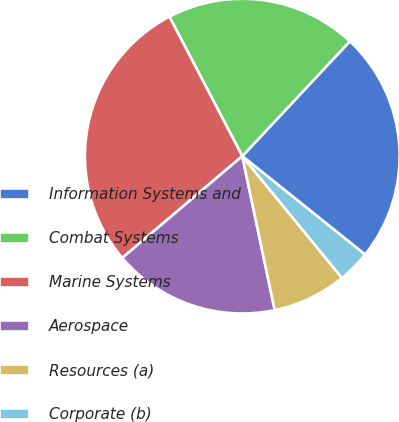Convert chart. <chart><loc_0><loc_0><loc_500><loc_500><pie_chart><fcel>Information Systems and<fcel>Combat Systems<fcel>Marine Systems<fcel>Aerospace<fcel>Resources (a)<fcel>Corporate (b)<nl><fcel>23.78%<fcel>19.64%<fcel>28.53%<fcel>17.12%<fcel>7.61%<fcel>3.33%<nl></chart> 